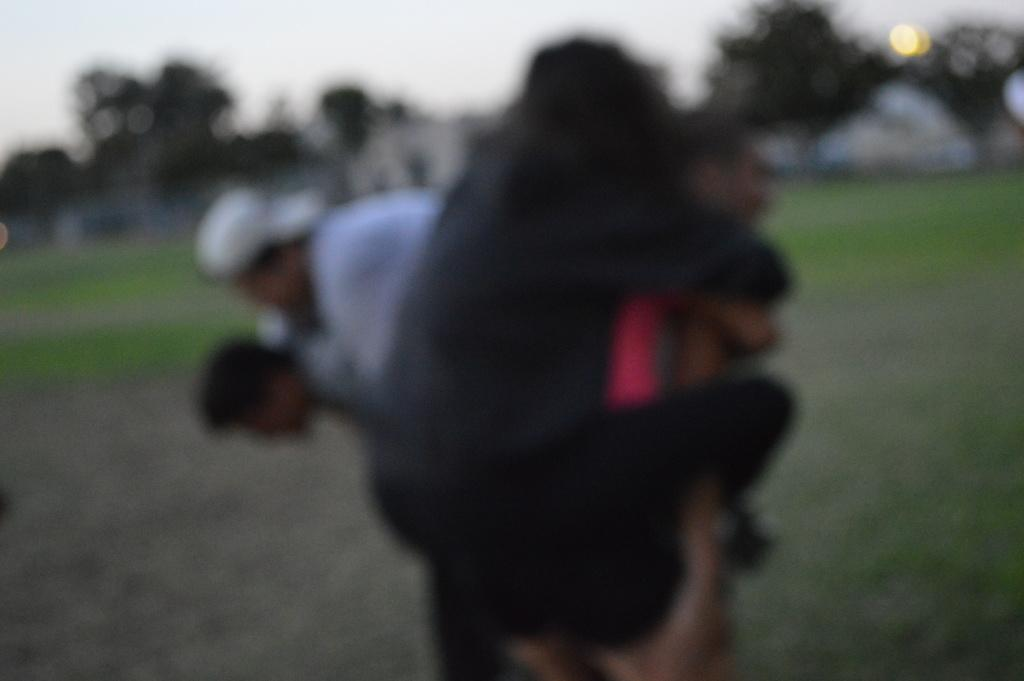How many people are in the foreground of the image? There are four persons in the foreground of the image. What is the surface the persons are standing on? The persons are on the grass. What can be seen in the background of the image? There are trees, houses, and the sky visible in the background of the image. From what perspective was the image taken? The image appears to be taken from the ground level. What type of honey can be seen dripping from the trees in the image? There is no honey present in the image; it features trees and houses in the background. 